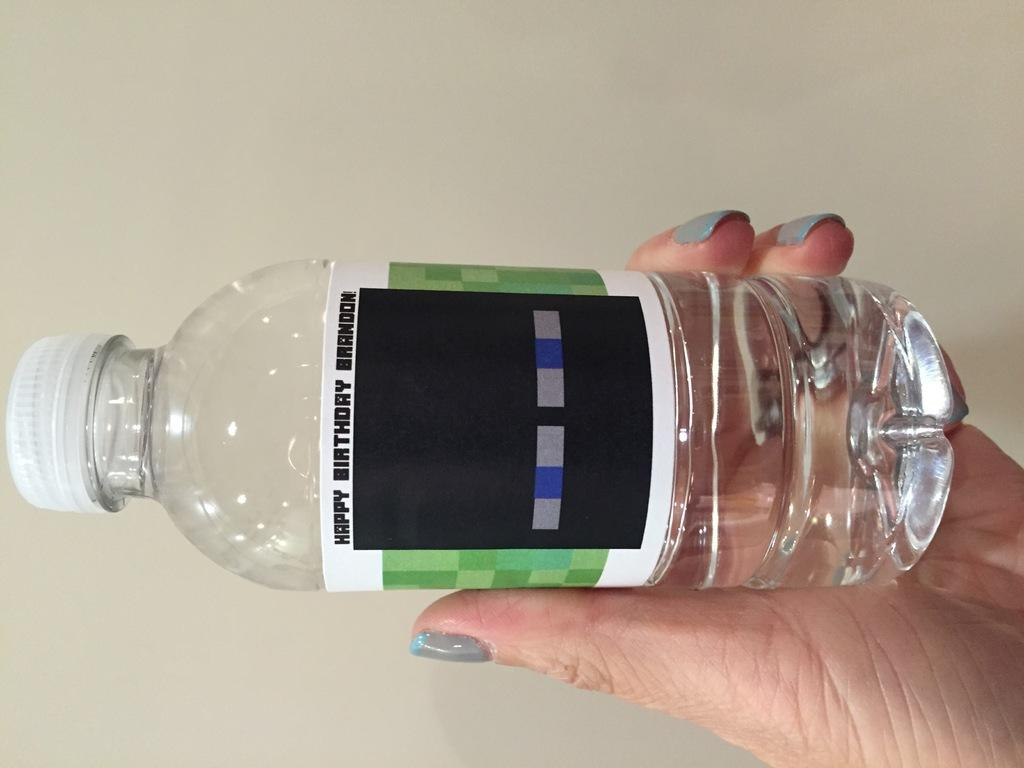Who or what is present in the image? There is a person in the image. What is the person holding in their hand? The person is holding a water bottle in their hand. How many bikes can be seen in the image? There are no bikes present in the image. What time of day is depicted in the image? The time of day cannot be determined from the image, as there is no information about lighting or shadows. 